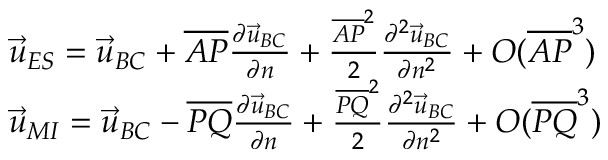<formula> <loc_0><loc_0><loc_500><loc_500>\begin{array} { r l } & { \vec { u } _ { E S } = \vec { u } _ { B C } + \overline { A P } \frac { \partial \vec { u } _ { B C } } { \partial n } + \frac { \overline { A P } ^ { 2 } } { 2 } \frac { \partial ^ { 2 } \vec { u } _ { B C } } { \partial n ^ { 2 } } + O ( \overline { A P } ^ { 3 } ) } \\ & { \vec { u } _ { M I } = \vec { u } _ { B C } - \overline { P Q } \frac { \partial \vec { u } _ { B C } } { \partial n } + \frac { \overline { P Q } ^ { 2 } } { 2 } \frac { \partial ^ { 2 } \vec { u } _ { B C } } { \partial n ^ { 2 } } + O ( \overline { P Q } ^ { 3 } ) } \end{array}</formula> 